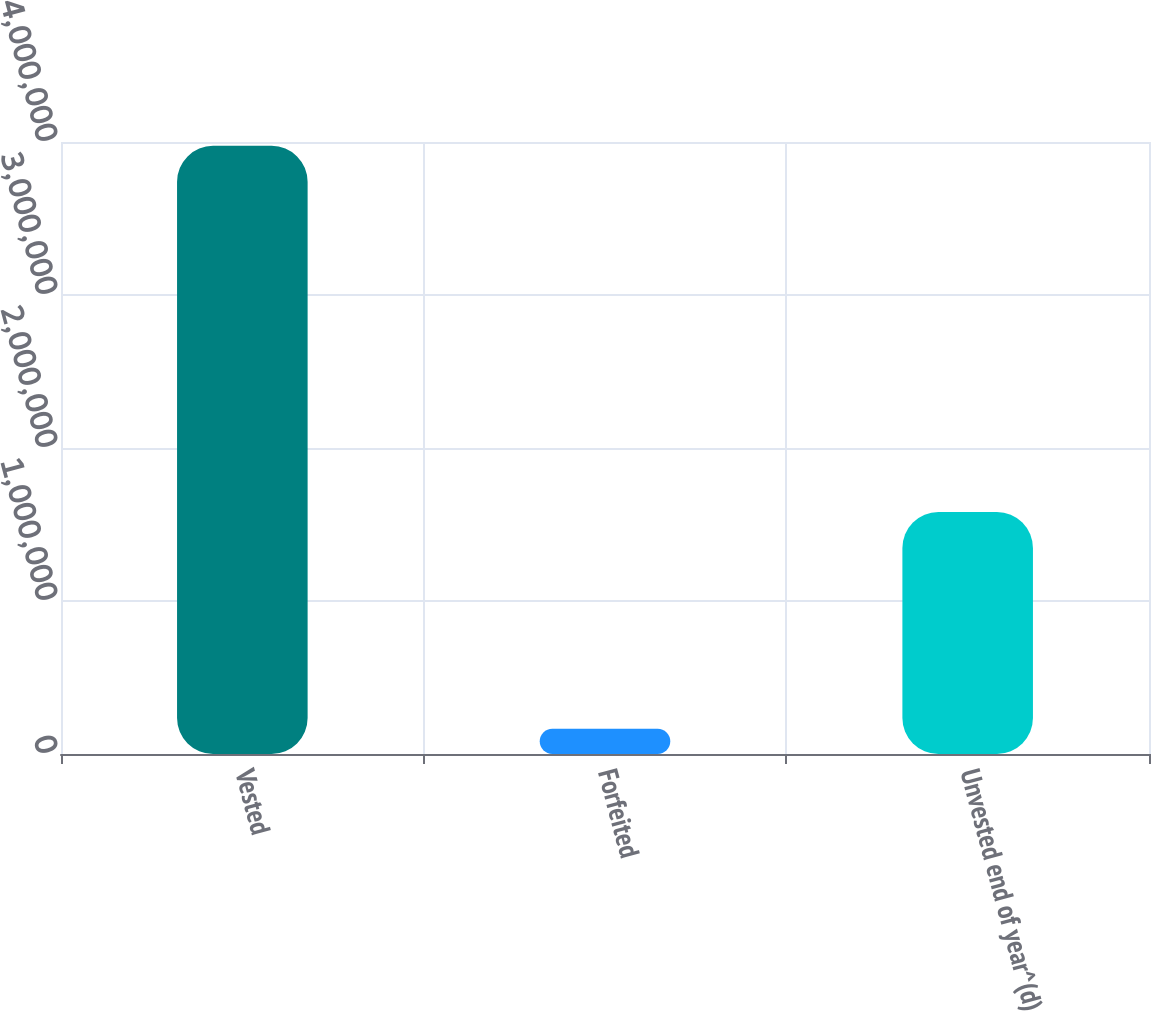Convert chart to OTSL. <chart><loc_0><loc_0><loc_500><loc_500><bar_chart><fcel>Vested<fcel>Forfeited<fcel>Unvested end of year^(d)<nl><fcel>3.97494e+06<fcel>165114<fcel>1.5819e+06<nl></chart> 